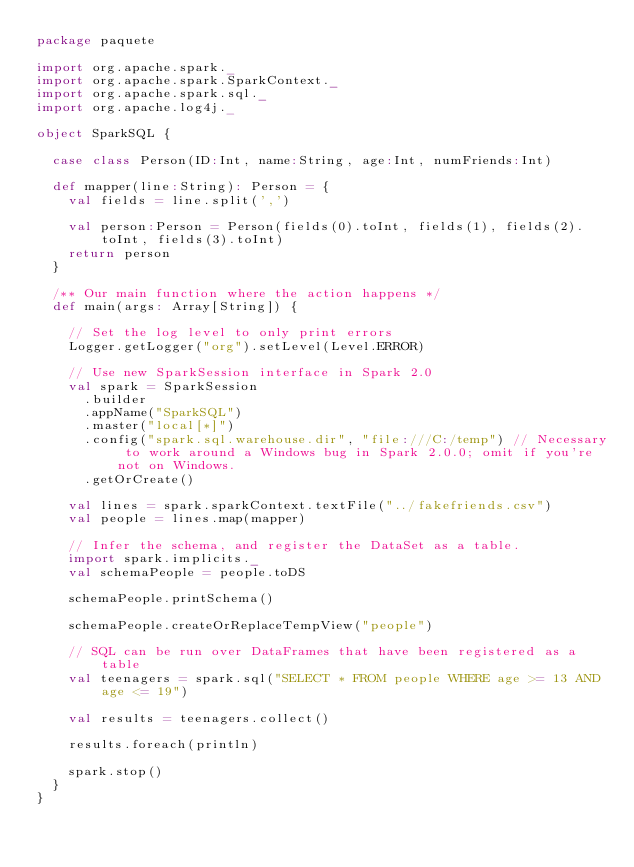<code> <loc_0><loc_0><loc_500><loc_500><_Scala_>package paquete

import org.apache.spark._
import org.apache.spark.SparkContext._
import org.apache.spark.sql._
import org.apache.log4j._

object SparkSQL {
  
  case class Person(ID:Int, name:String, age:Int, numFriends:Int)
  
  def mapper(line:String): Person = {
    val fields = line.split(',')  
    
    val person:Person = Person(fields(0).toInt, fields(1), fields(2).toInt, fields(3).toInt)
    return person
  }
  
  /** Our main function where the action happens */
  def main(args: Array[String]) {
    
    // Set the log level to only print errors
    Logger.getLogger("org").setLevel(Level.ERROR)
    
    // Use new SparkSession interface in Spark 2.0
    val spark = SparkSession
      .builder
      .appName("SparkSQL")
      .master("local[*]")
      .config("spark.sql.warehouse.dir", "file:///C:/temp") // Necessary to work around a Windows bug in Spark 2.0.0; omit if you're not on Windows.
      .getOrCreate()
    
    val lines = spark.sparkContext.textFile("../fakefriends.csv")
    val people = lines.map(mapper)
    
    // Infer the schema, and register the DataSet as a table.
    import spark.implicits._
    val schemaPeople = people.toDS
    
    schemaPeople.printSchema()
    
    schemaPeople.createOrReplaceTempView("people")
    
    // SQL can be run over DataFrames that have been registered as a table
    val teenagers = spark.sql("SELECT * FROM people WHERE age >= 13 AND age <= 19")
    
    val results = teenagers.collect()
    
    results.foreach(println)
    
    spark.stop()
  }
}</code> 